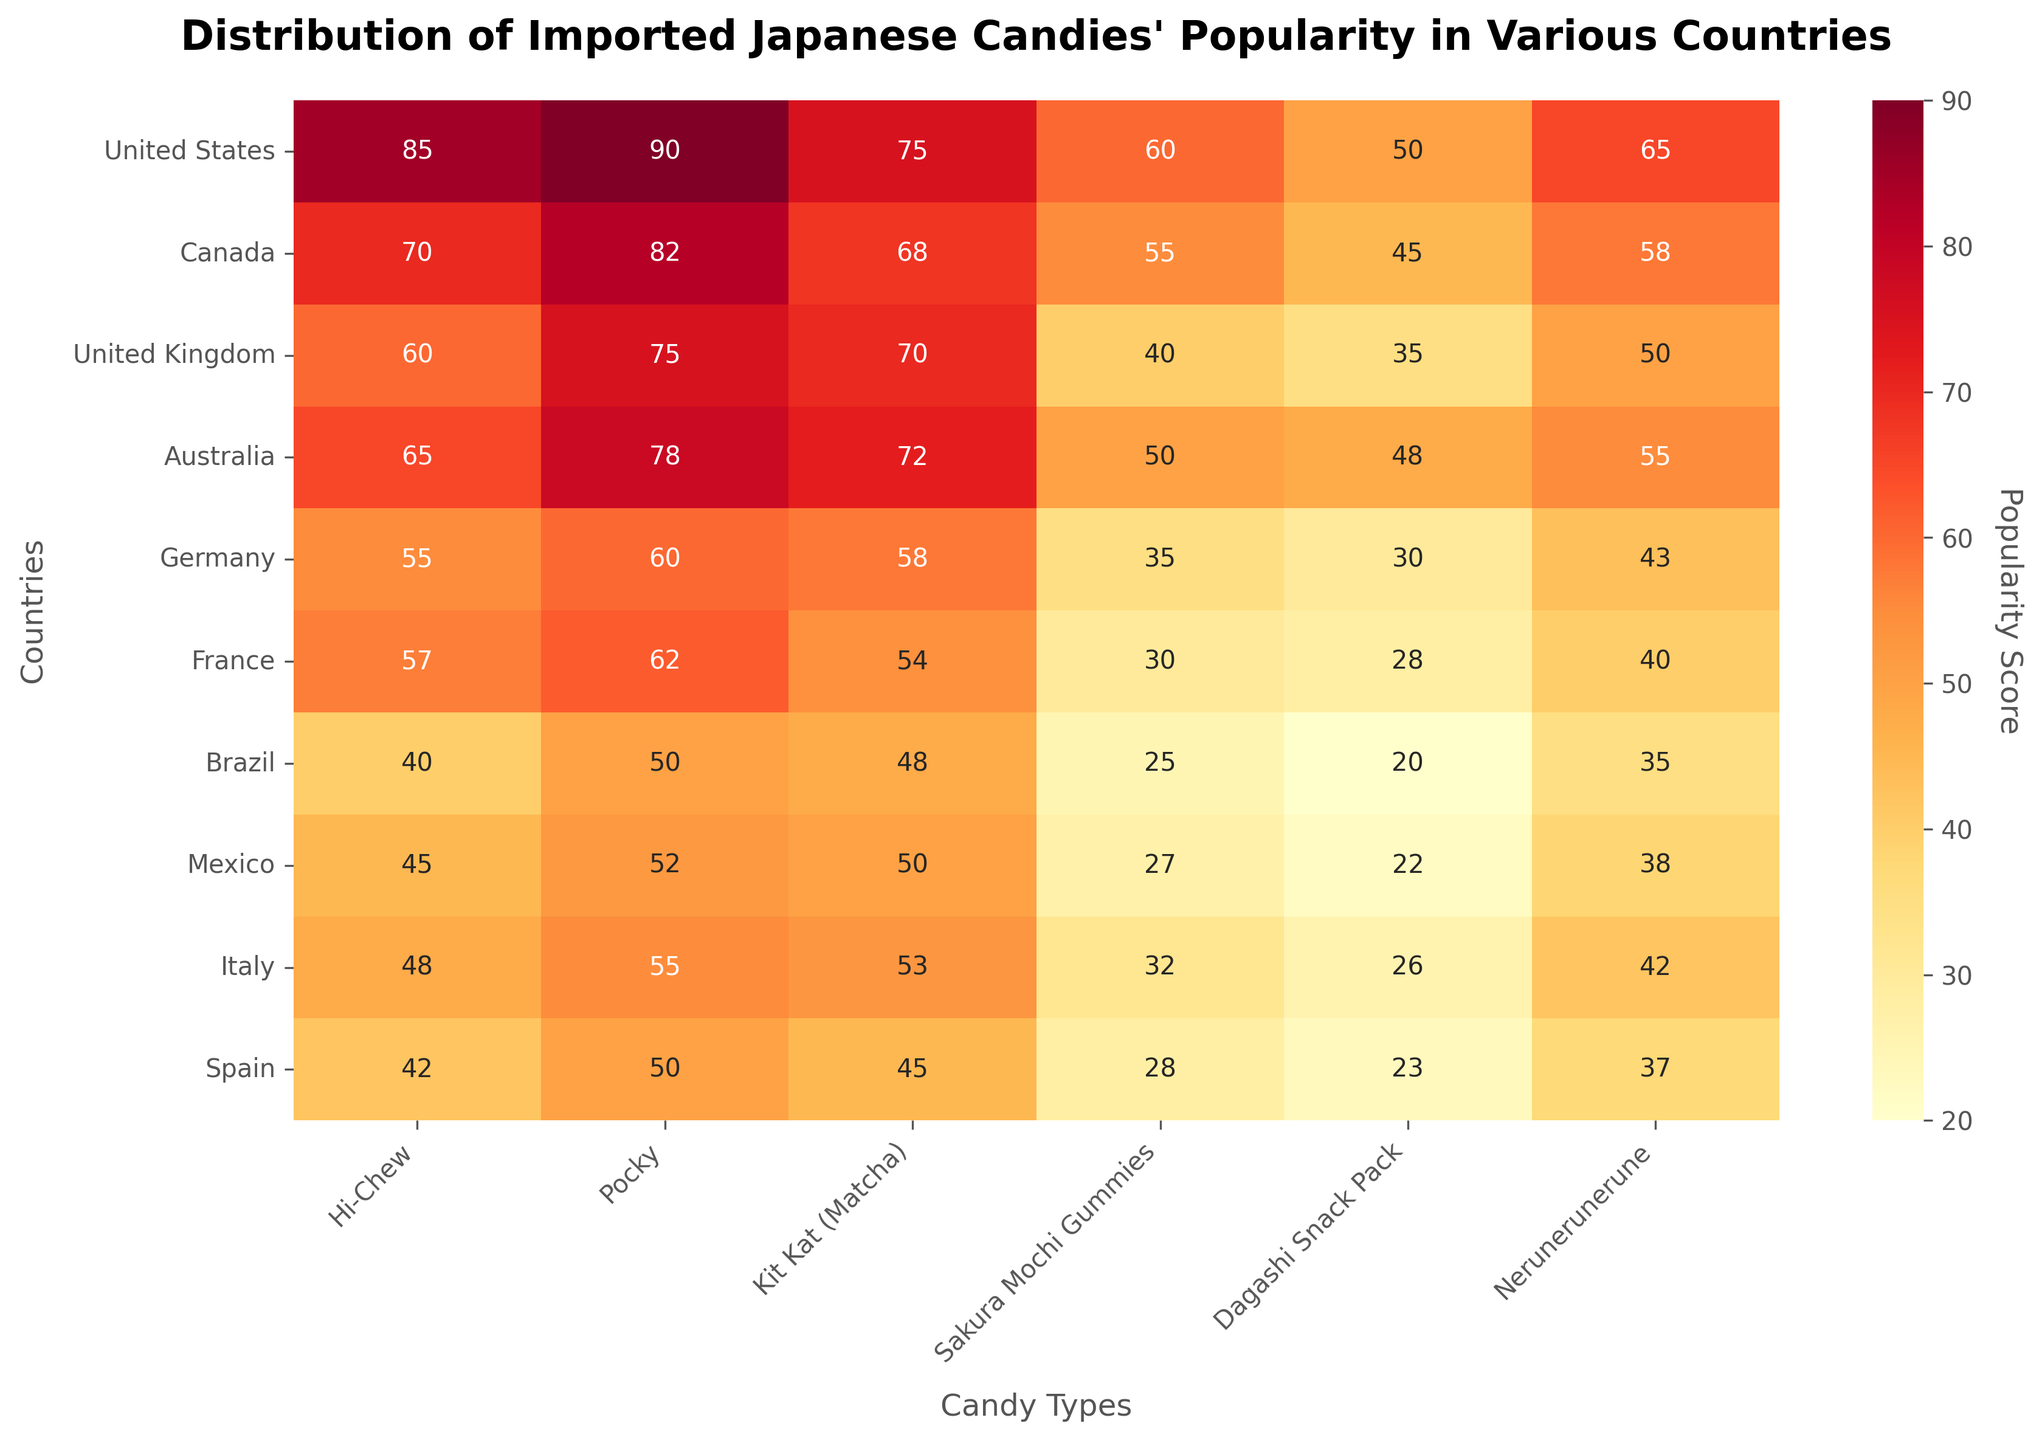What is the title of the figure? The title of the figure is found at the top of the heatmap, typically in bold font to highlight what the plotted data represents.
Answer: Distribution of Imported Japanese Candies' Popularity in Various Countries Which country shows the highest popularity for Hi-Chew? Look at the heatmap under the "Hi-Chew" column and find the cell with the highest value. Then, trace that cell to the corresponding country on the y-axis.
Answer: United States What is the average popularity score of Pocky across all countries? Sum the popularity scores of Pocky across all countries and divide by the number of countries. The scores are 90, 82, 75, 78, 60, 62, 50, 52, 55, and 50. Their sum is 654, and there are 10 countries, so the average is 654/10.
Answer: 65.4 Which candy has the lowest popularity in France? Check the values in the France row across all candy columns and identify the lowest value. Then, trace it to the corresponding candy on the x-axis.
Answer: Sakura Mochi Gummies Compare the popularity of Kit Kat (Matcha) in Germany and Spain. Which country has a higher popularity score, and by how much? Locate the values for Kit Kat (Matcha) in Germany and Spain. Germany has a score of 58, while Spain has a score of 45. The difference is 58 - 45.
Answer: Germany, by 13 Which candy type shows the smallest popularity range across all countries? For each candy type, calculate the difference between its highest and lowest popularity scores across all countries. The candy with the smallest difference is the answer.
Answer: Dagashi Snack Pack How does the popularity of Nerunerunerune in Australia compare to its popularity in Mexico? Look at the values for Nerunerunerune under Australia and Mexico. The value for Australia is 55 and for Mexico is 38. Australia has a higher value.
Answer: Higher in Australia What is the sum of the popularity scores for Dagashi Snack Pack in the United States, Canada, and the United Kingdom? Identify and sum the values in the Dagashi Snack Pack column for the United States (50), Canada (45), and the United Kingdom (35). The sum is 50 + 45 + 35.
Answer: 130 Which country shows the highest average popularity across all candies, and what is that average? Compute the average popularity for each country. Sum the values for each candy in the country and divide by the number of candies (6). The country with the highest average score is the answer.
Answer: United States, 70.83 Identify the country where the popularity of Sakura Mochi Gummies exceeds 50. Check the Sakura Mochi Gummies column and find which country(ies) have a value greater than 50. Only one country meets this criterion.
Answer: United States 